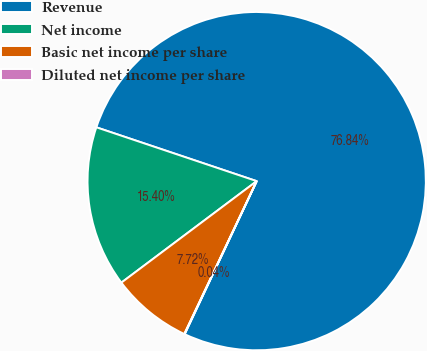Convert chart. <chart><loc_0><loc_0><loc_500><loc_500><pie_chart><fcel>Revenue<fcel>Net income<fcel>Basic net income per share<fcel>Diluted net income per share<nl><fcel>76.85%<fcel>15.4%<fcel>7.72%<fcel>0.04%<nl></chart> 